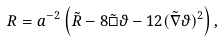Convert formula to latex. <formula><loc_0><loc_0><loc_500><loc_500>R = a ^ { - 2 } \left ( \tilde { R } - 8 \tilde { \Box } \vartheta - 1 2 ( \tilde { \nabla } \vartheta ) ^ { 2 } \right ) ,</formula> 